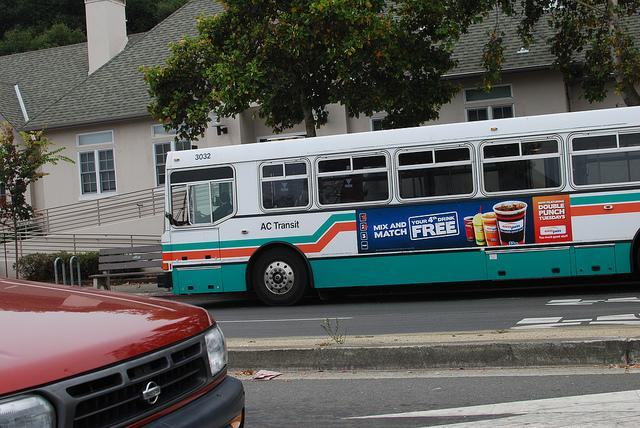What day is Double Punch? Please explain your reasoning. tuesday. The day is tuesday. 